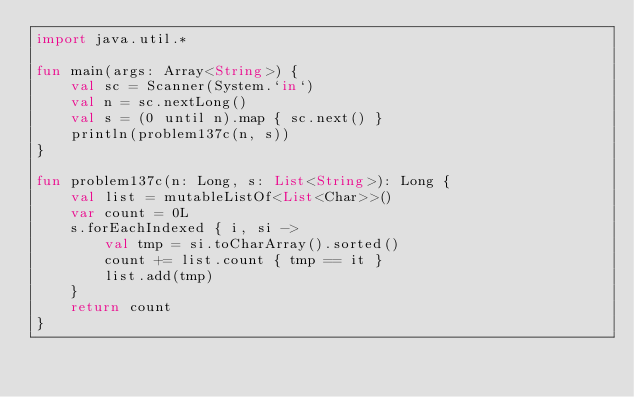<code> <loc_0><loc_0><loc_500><loc_500><_Kotlin_>import java.util.*

fun main(args: Array<String>) {
    val sc = Scanner(System.`in`)
    val n = sc.nextLong()
    val s = (0 until n).map { sc.next() }
    println(problem137c(n, s))
}

fun problem137c(n: Long, s: List<String>): Long {
    val list = mutableListOf<List<Char>>()
    var count = 0L
    s.forEachIndexed { i, si ->
        val tmp = si.toCharArray().sorted()
        count += list.count { tmp == it }
        list.add(tmp)
    }
    return count
}</code> 